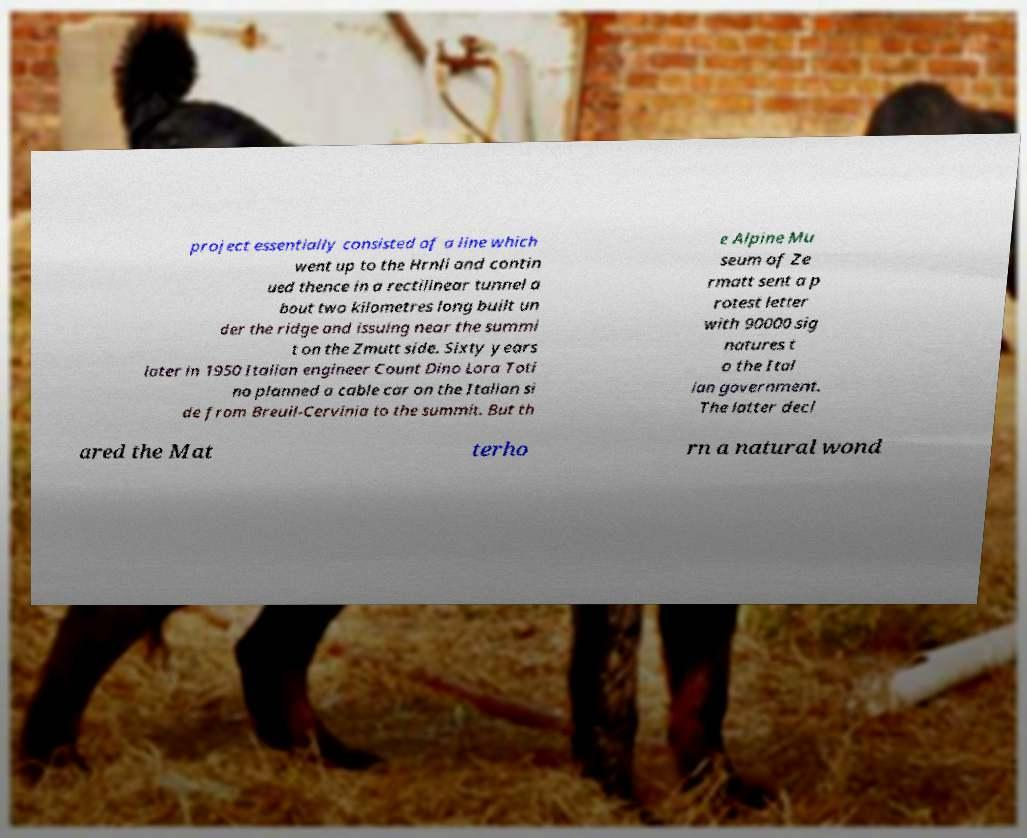What messages or text are displayed in this image? I need them in a readable, typed format. project essentially consisted of a line which went up to the Hrnli and contin ued thence in a rectilinear tunnel a bout two kilometres long built un der the ridge and issuing near the summi t on the Zmutt side. Sixty years later in 1950 Italian engineer Count Dino Lora Toti no planned a cable car on the Italian si de from Breuil-Cervinia to the summit. But th e Alpine Mu seum of Ze rmatt sent a p rotest letter with 90000 sig natures t o the Ital ian government. The latter decl ared the Mat terho rn a natural wond 